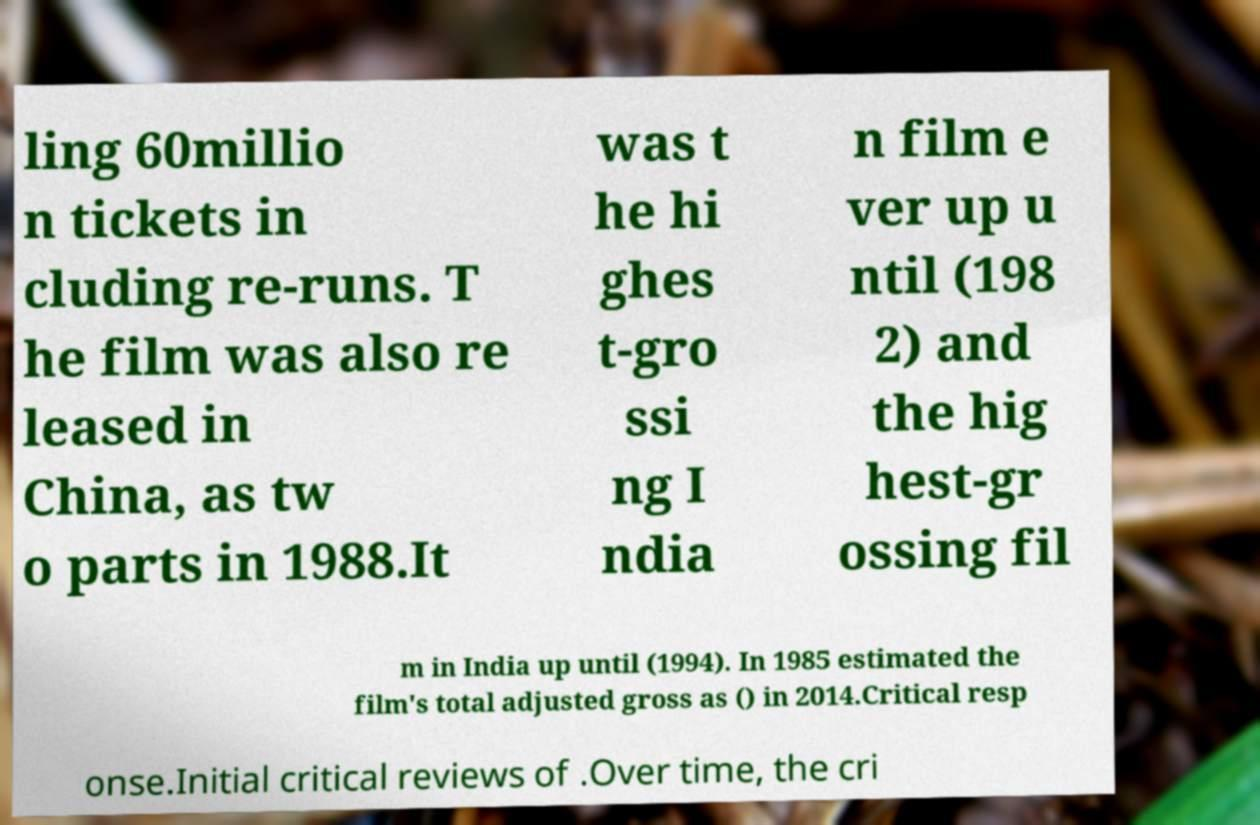What messages or text are displayed in this image? I need them in a readable, typed format. ling 60millio n tickets in cluding re-runs. T he film was also re leased in China, as tw o parts in 1988.It was t he hi ghes t-gro ssi ng I ndia n film e ver up u ntil (198 2) and the hig hest-gr ossing fil m in India up until (1994). In 1985 estimated the film's total adjusted gross as () in 2014.Critical resp onse.Initial critical reviews of .Over time, the cri 